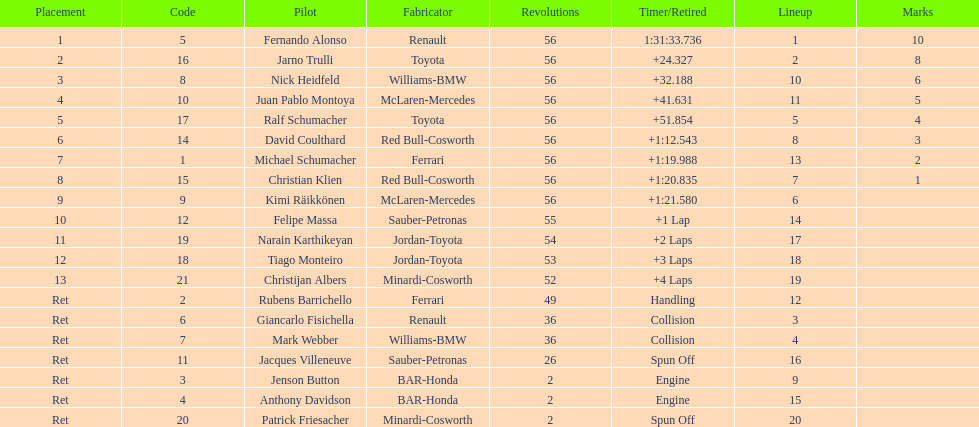Who was the last driver to actually finish the race? Christijan Albers. 